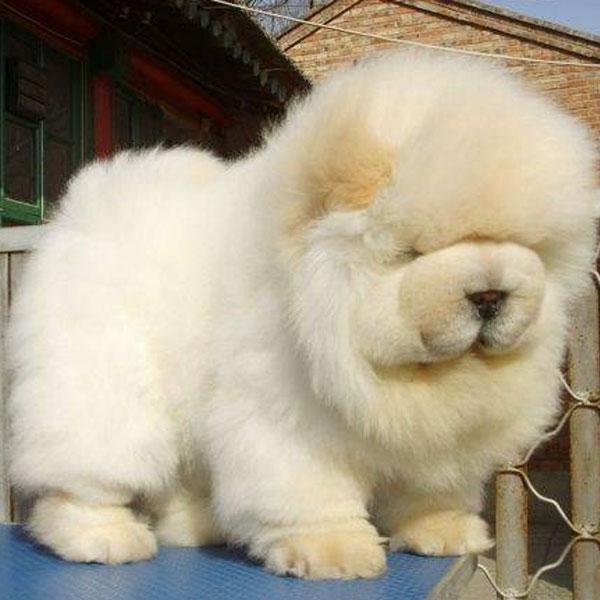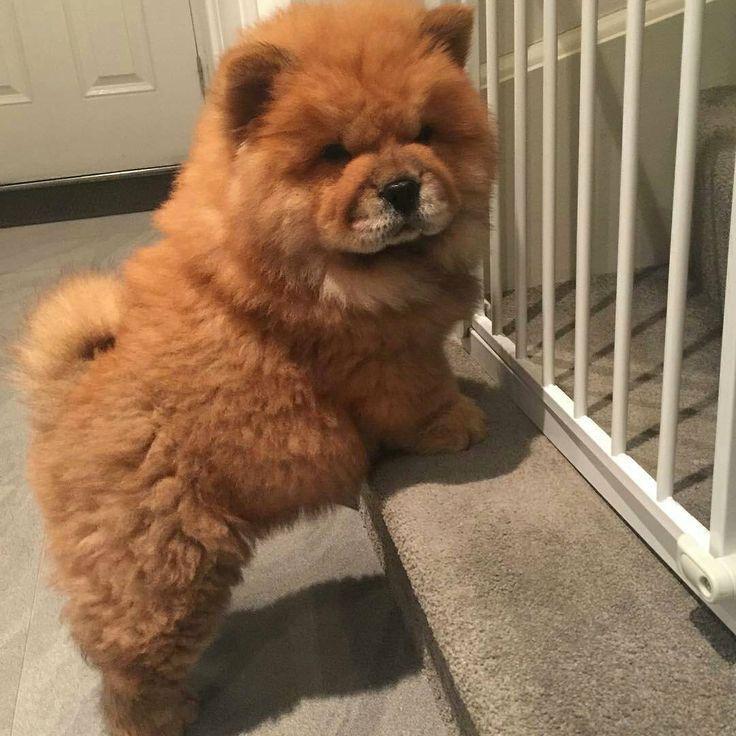The first image is the image on the left, the second image is the image on the right. Given the left and right images, does the statement "In one image, a small white dog is beside driftwood and in front of a wooden wall." hold true? Answer yes or no. No. The first image is the image on the left, the second image is the image on the right. Considering the images on both sides, is "An image shows three chow pups on a plush surface." valid? Answer yes or no. No. 